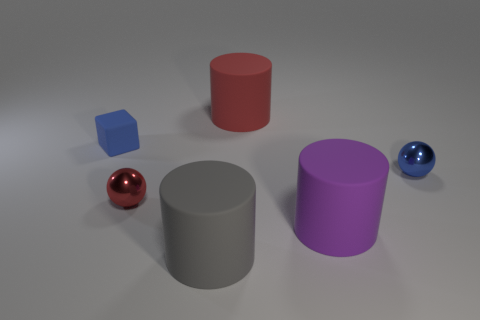Add 2 green shiny blocks. How many objects exist? 8 Subtract all cubes. How many objects are left? 5 Add 5 red cylinders. How many red cylinders exist? 6 Subtract 0 yellow blocks. How many objects are left? 6 Subtract all red objects. Subtract all purple cylinders. How many objects are left? 3 Add 2 tiny blue metal things. How many tiny blue metal things are left? 3 